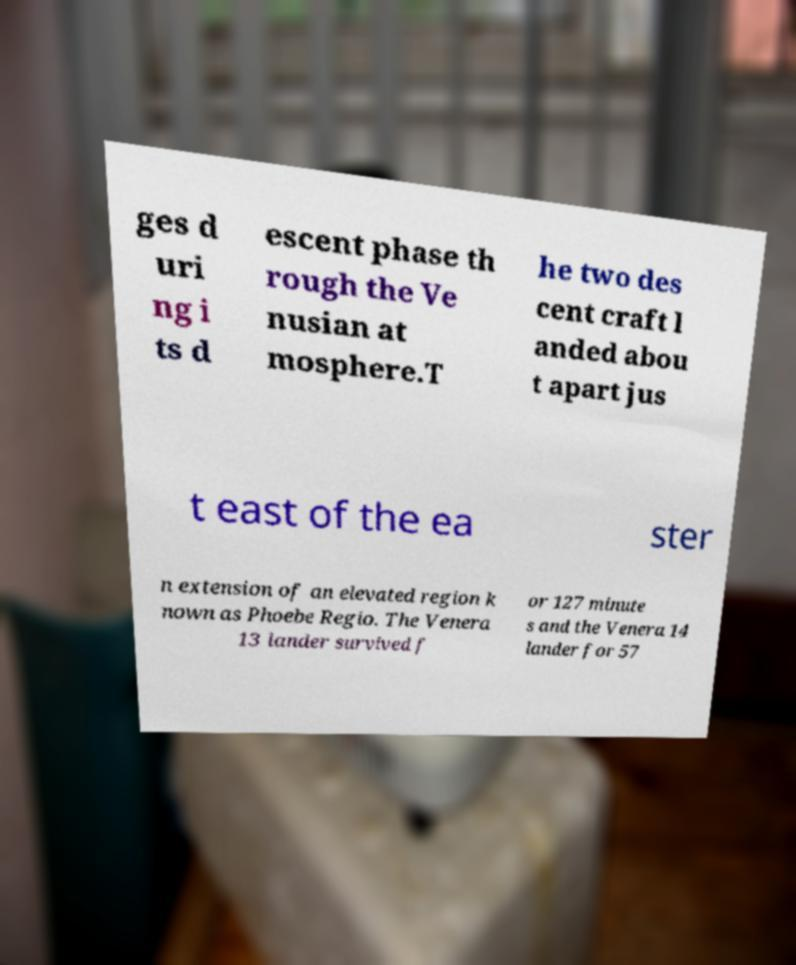I need the written content from this picture converted into text. Can you do that? ges d uri ng i ts d escent phase th rough the Ve nusian at mosphere.T he two des cent craft l anded abou t apart jus t east of the ea ster n extension of an elevated region k nown as Phoebe Regio. The Venera 13 lander survived f or 127 minute s and the Venera 14 lander for 57 